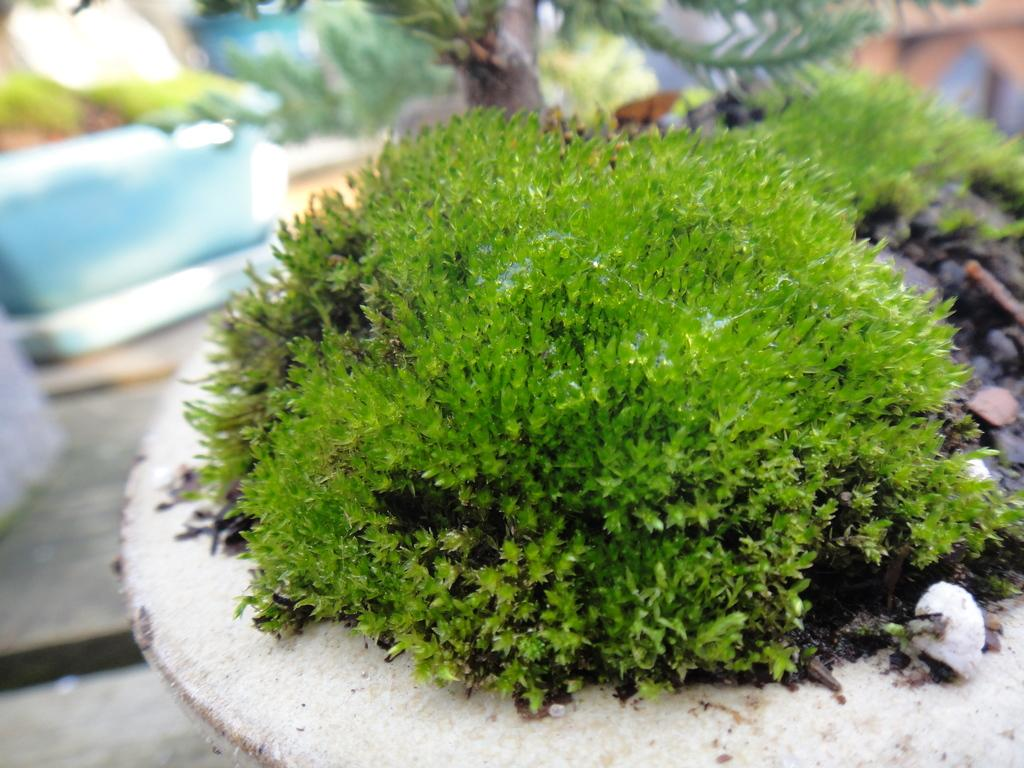What type of plants are in the image? There are plants in pots with rocks in the image. Where is the basket located in the image? The basket is on the left side of the image. What is inside the basket? The basket contains objects. On what surface is the basket placed? The basket is placed on the floor. What type of leather is visible in the image? There is no leather present in the image. What season is depicted in the image? The image does not depict a specific season, as there are no seasonal cues present. 